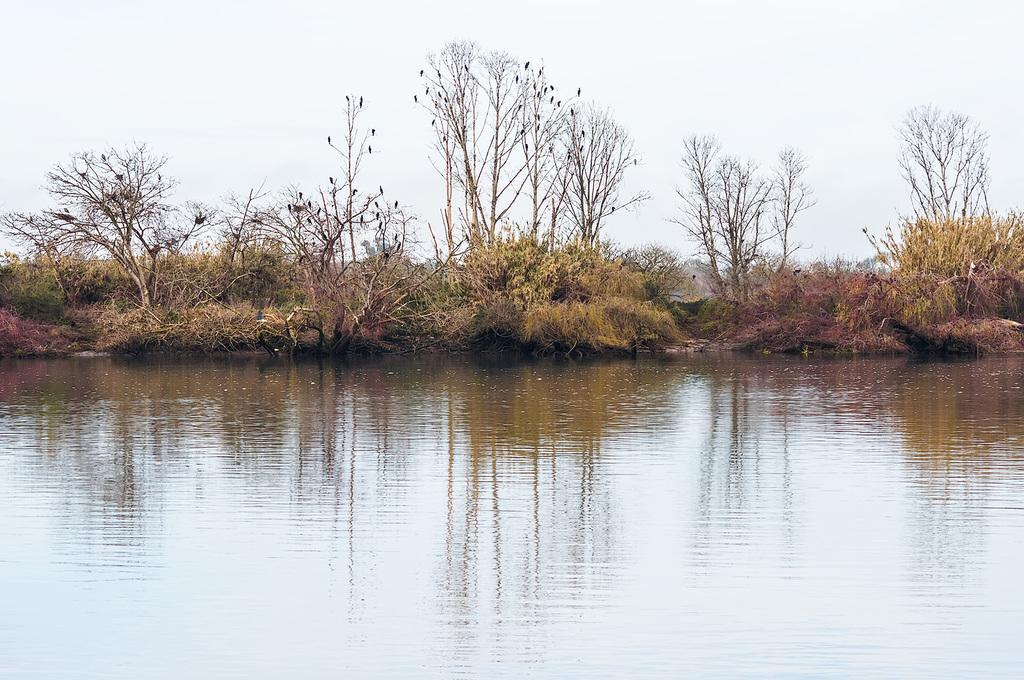What is the primary element visible in the picture? There is water in the picture. What can be seen in the background of the picture? There are plants and trees in the background of the picture. What type of can is visible in the picture? There is no can present in the picture; it features water and background elements like plants and trees. 